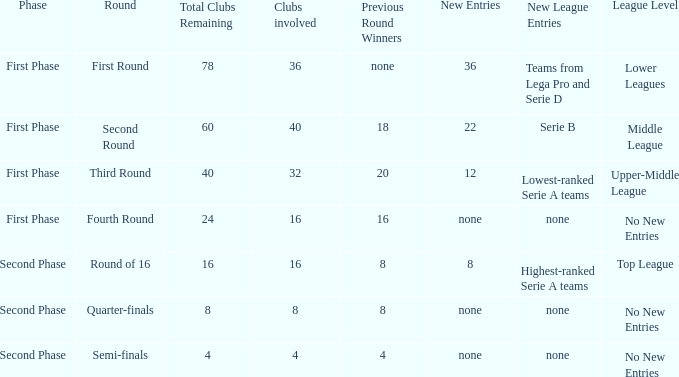The new entries this round was shown to be 12, in which phase would you find this? First Phase. 